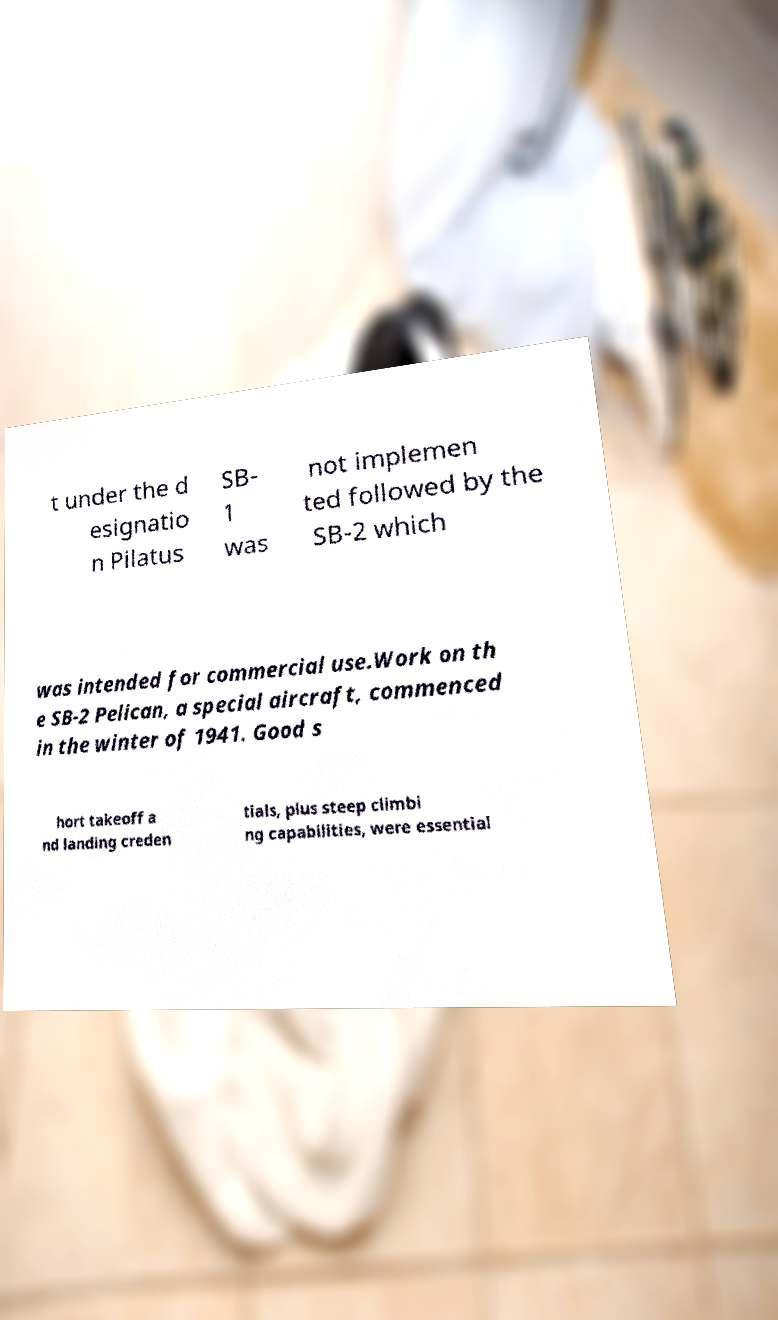Could you extract and type out the text from this image? t under the d esignatio n Pilatus SB- 1 was not implemen ted followed by the SB-2 which was intended for commercial use.Work on th e SB-2 Pelican, a special aircraft, commenced in the winter of 1941. Good s hort takeoff a nd landing creden tials, plus steep climbi ng capabilities, were essential 